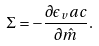<formula> <loc_0><loc_0><loc_500><loc_500>\Sigma = - \frac { \partial \epsilon _ { v } a c } { \partial \hat { m } } .</formula> 